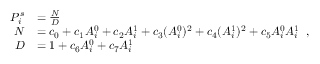<formula> <loc_0><loc_0><loc_500><loc_500>\begin{array} { r l } { P _ { i } ^ { s } } & { = \frac { N } { D } } \\ { N } & { = c _ { 0 } + c _ { 1 } A _ { i } ^ { 0 } + c _ { 2 } A _ { i } ^ { 1 } + c _ { 3 } ( A _ { i } ^ { 0 } ) ^ { 2 } + c _ { 4 } ( A _ { i } ^ { 1 } ) ^ { 2 } + c _ { 5 } A _ { i } ^ { 0 } A _ { i } ^ { 1 } } \\ { D } & { = 1 + c _ { 6 } A _ { i } ^ { 0 } + c _ { 7 } A _ { i } ^ { 1 } } \end{array} ,</formula> 